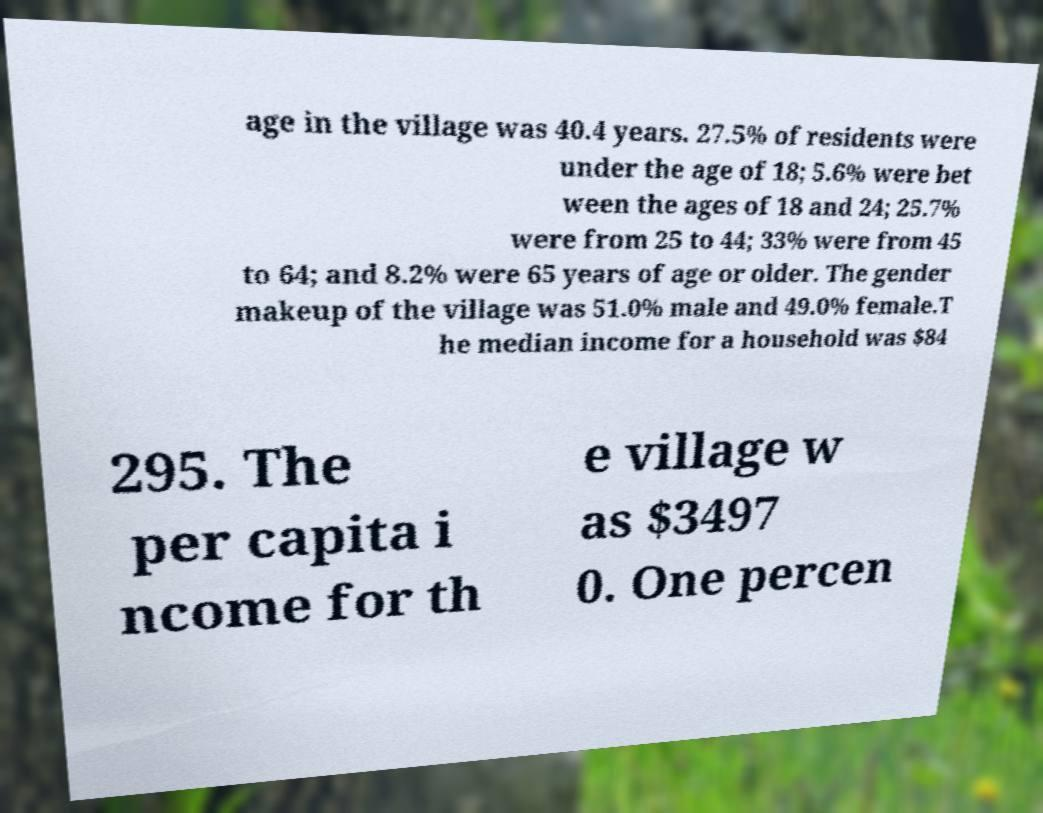Could you extract and type out the text from this image? age in the village was 40.4 years. 27.5% of residents were under the age of 18; 5.6% were bet ween the ages of 18 and 24; 25.7% were from 25 to 44; 33% were from 45 to 64; and 8.2% were 65 years of age or older. The gender makeup of the village was 51.0% male and 49.0% female.T he median income for a household was $84 295. The per capita i ncome for th e village w as $3497 0. One percen 